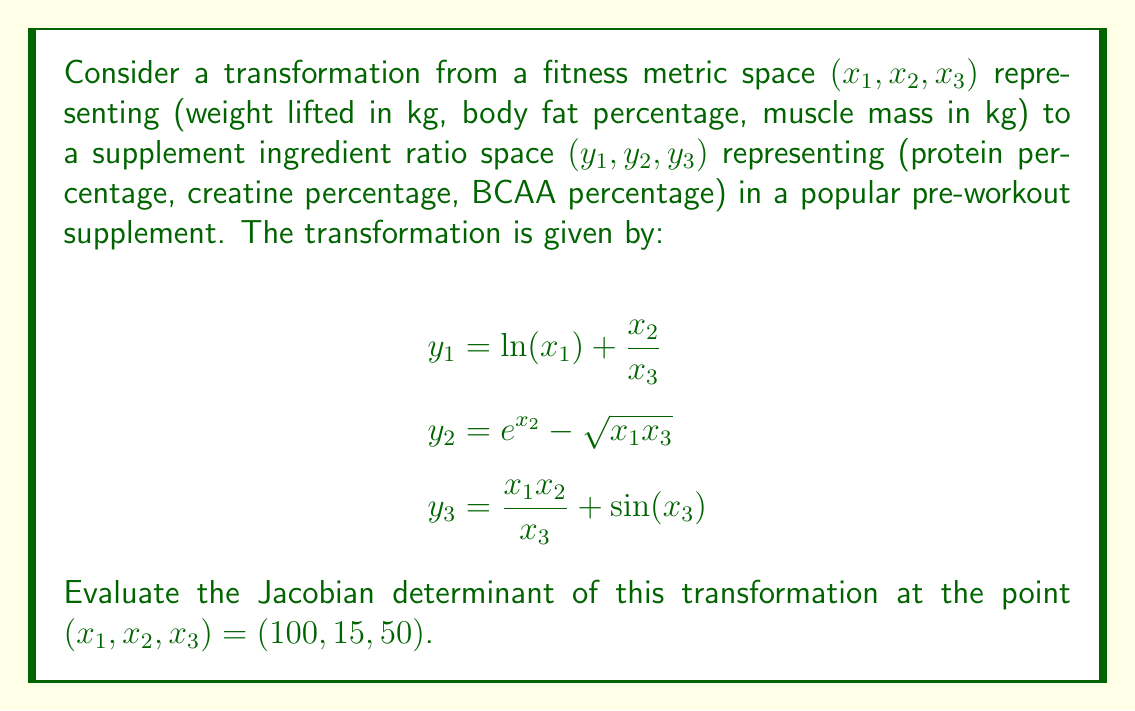Teach me how to tackle this problem. To evaluate the Jacobian determinant, we need to follow these steps:

1) First, we calculate the Jacobian matrix by finding the partial derivatives of each $y_i$ with respect to each $x_j$:

   $$J = \begin{bmatrix}
   \frac{\partial y_1}{\partial x_1} & \frac{\partial y_1}{\partial x_2} & \frac{\partial y_1}{\partial x_3} \\
   \frac{\partial y_2}{\partial x_1} & \frac{\partial y_2}{\partial x_2} & \frac{\partial y_2}{\partial x_3} \\
   \frac{\partial y_3}{\partial x_1} & \frac{\partial y_3}{\partial x_2} & \frac{\partial y_3}{\partial x_3}
   \end{bmatrix}$$

2) Calculating each partial derivative:

   $$\begin{aligned}
   \frac{\partial y_1}{\partial x_1} &= \frac{1}{x_1} & \frac{\partial y_1}{\partial x_2} &= \frac{1}{x_3} & \frac{\partial y_1}{\partial x_3} &= -\frac{x_2}{x_3^2} \\
   \frac{\partial y_2}{\partial x_1} &= -\frac{x_3}{2\sqrt{x_1x_3}} & \frac{\partial y_2}{\partial x_2} &= e^{x_2} & \frac{\partial y_2}{\partial x_3} &= -\frac{x_1}{2\sqrt{x_1x_3}} \\
   \frac{\partial y_3}{\partial x_1} &= \frac{x_2}{x_3} & \frac{\partial y_3}{\partial x_2} &= \frac{x_1}{x_3} & \frac{\partial y_3}{\partial x_3} &= -\frac{x_1x_2}{x_3^2} + \cos(x_3)
   \end{aligned}$$

3) Substituting the given point $(100, 15, 50)$ into the Jacobian matrix:

   $$J = \begin{bmatrix}
   \frac{1}{100} & \frac{1}{50} & -\frac{15}{50^2} \\
   -\frac{50}{2\sqrt{100 \cdot 50}} & e^{15} & -\frac{100}{2\sqrt{100 \cdot 50}} \\
   \frac{15}{50} & \frac{100}{50} & -\frac{100 \cdot 15}{50^2} + \cos(50)
   \end{bmatrix}$$

4) Simplifying:

   $$J = \begin{bmatrix}
   0.01 & 0.02 & -0.006 \\
   -0.05 & e^{15} & -0.1 \\
   0.3 & 2 & -0.6 + \cos(50)
   \end{bmatrix}$$

5) The Jacobian determinant is the determinant of this matrix. We can calculate it using the first row expansion:

   $$\begin{aligned}
   \det(J) &= 0.01 \cdot \begin{vmatrix} e^{15} & -0.1 \\ 2 & -0.6 + \cos(50) \end{vmatrix} \\
   &- 0.02 \cdot \begin{vmatrix} -0.05 & -0.1 \\ 0.3 & -0.6 + \cos(50) \end{vmatrix} \\
   &+ (-0.006) \cdot \begin{vmatrix} -0.05 & e^{15} \\ 0.3 & 2 \end{vmatrix}
   \end{aligned}$$

6) Calculating each 2x2 determinant:

   $$\begin{aligned}
   \det(J) &= 0.01 \cdot [e^{15}(-0.6 + \cos(50)) + 0.2] \\
   &- 0.02 \cdot [0.05(-0.6 + \cos(50)) - 0.03] \\
   &+ (-0.006) \cdot [-0.1 - 0.3e^{15}]
   \end{aligned}$$

7) Simplifying and calculating the final result:

   $$\det(J) \approx 0.01e^{15}(-0.6 + \cos(50)) + 0.002 - 0.001(-0.6 + \cos(50)) + 0.0006 + 0.0006 + 0.0018e^{15}$$

   $$\det(J) \approx 3267.63$$
Answer: $3267.63$ 